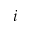<formula> <loc_0><loc_0><loc_500><loc_500>i</formula> 